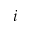<formula> <loc_0><loc_0><loc_500><loc_500>i</formula> 